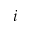<formula> <loc_0><loc_0><loc_500><loc_500>i</formula> 